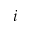<formula> <loc_0><loc_0><loc_500><loc_500>i</formula> 